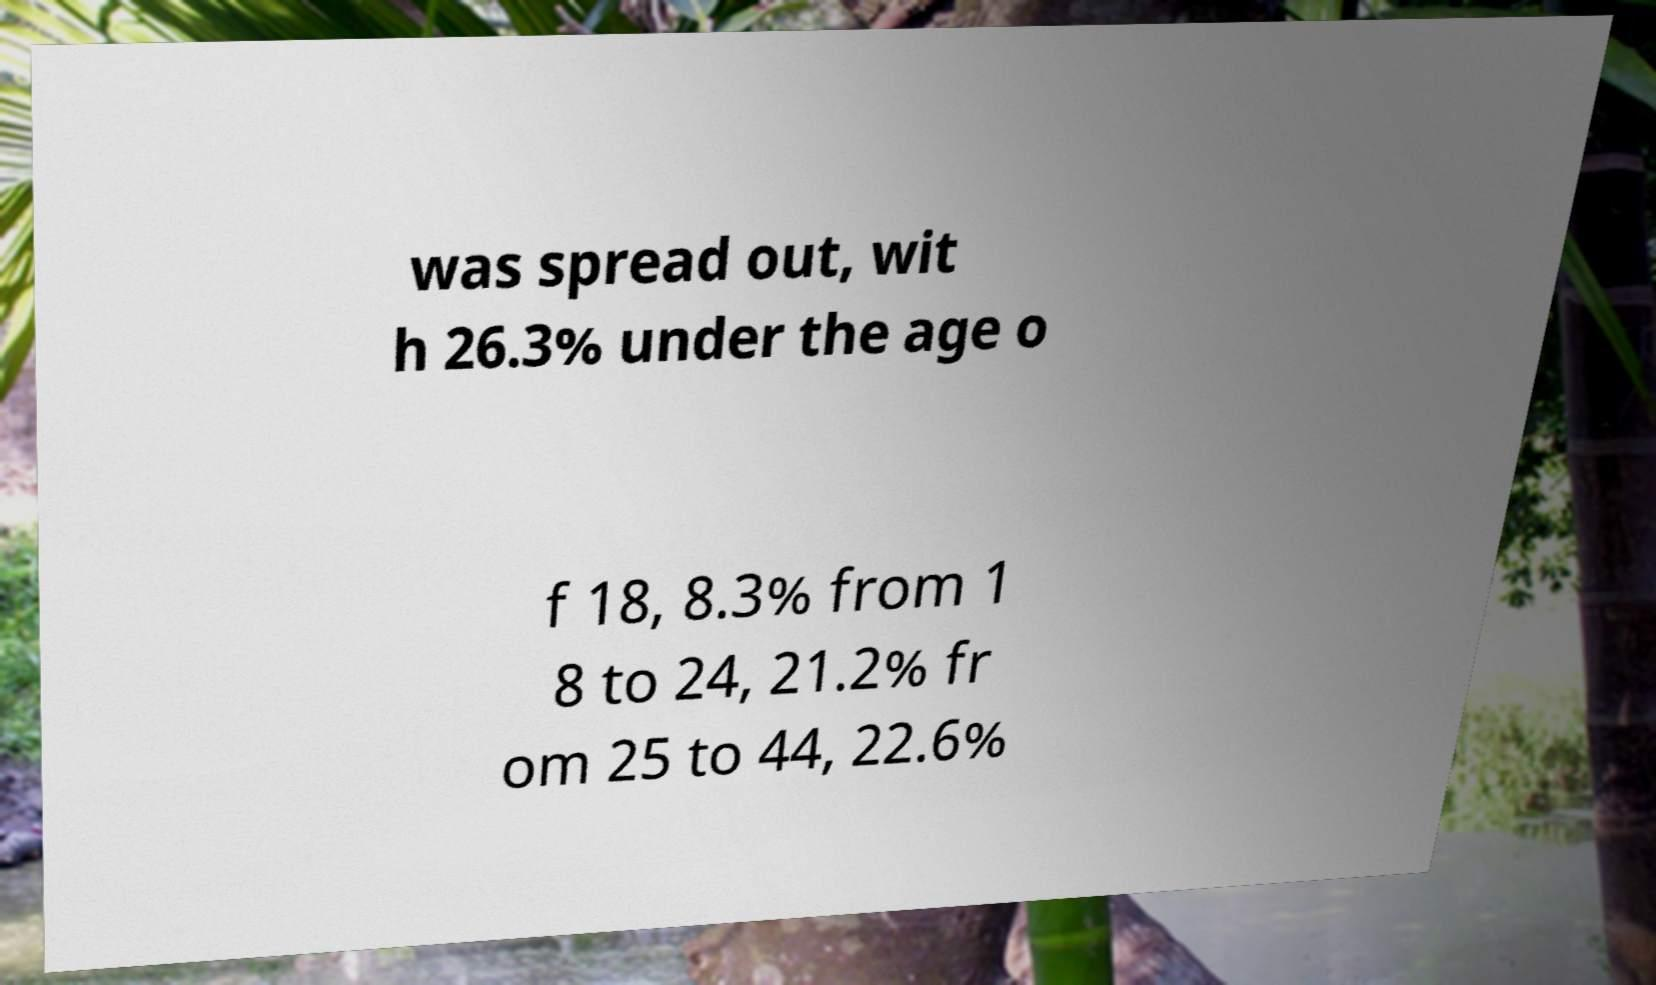What messages or text are displayed in this image? I need them in a readable, typed format. was spread out, wit h 26.3% under the age o f 18, 8.3% from 1 8 to 24, 21.2% fr om 25 to 44, 22.6% 